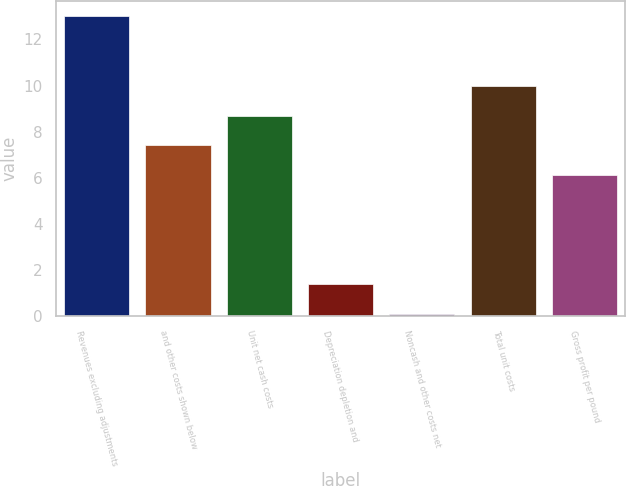Convert chart to OTSL. <chart><loc_0><loc_0><loc_500><loc_500><bar_chart><fcel>Revenues excluding adjustments<fcel>and other costs shown below<fcel>Unit net cash costs<fcel>Depreciation depletion and<fcel>Noncash and other costs net<fcel>Total unit costs<fcel>Gross profit per pound<nl><fcel>13<fcel>7.4<fcel>8.69<fcel>1.38<fcel>0.09<fcel>9.98<fcel>6.11<nl></chart> 